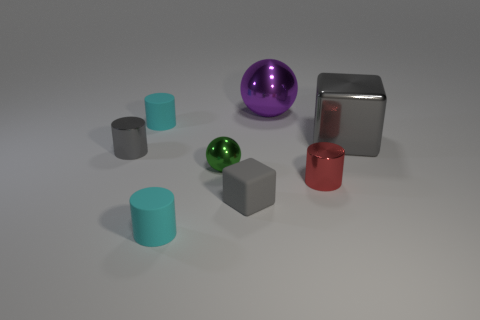Are the purple object and the gray object that is to the right of the large purple shiny object made of the same material?
Offer a very short reply. Yes. What number of objects are either blocks or small cyan rubber things?
Your answer should be very brief. 4. Is there a cyan rubber cylinder?
Ensure brevity in your answer.  Yes. There is a large object that is on the right side of the shiny cylinder that is to the right of the gray matte thing; what is its shape?
Offer a very short reply. Cube. What number of objects are tiny things in front of the green ball or large shiny objects that are left of the large gray thing?
Your response must be concise. 4. There is a block that is the same size as the red metal cylinder; what is its material?
Ensure brevity in your answer.  Rubber. The small sphere is what color?
Make the answer very short. Green. There is a gray object that is both in front of the gray shiny block and right of the small metal ball; what material is it?
Make the answer very short. Rubber. There is a cube that is left of the tiny metal cylinder that is to the right of the green metal sphere; is there a cyan matte cylinder to the right of it?
Your answer should be very brief. No. There is a metallic cylinder that is the same color as the metallic block; what is its size?
Offer a very short reply. Small. 